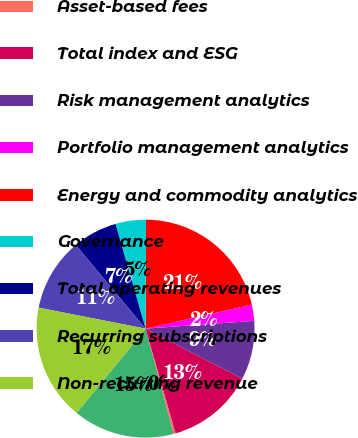Convert chart to OTSL. <chart><loc_0><loc_0><loc_500><loc_500><pie_chart><fcel>Subscriptions<fcel>Asset-based fees<fcel>Total index and ESG<fcel>Risk management analytics<fcel>Portfolio management analytics<fcel>Energy and commodity analytics<fcel>Governance<fcel>Total operating revenues<fcel>Recurring subscriptions<fcel>Non-recurring revenue<nl><fcel>15.06%<fcel>0.29%<fcel>12.95%<fcel>8.73%<fcel>2.4%<fcel>21.39%<fcel>4.51%<fcel>6.62%<fcel>10.84%<fcel>17.17%<nl></chart> 